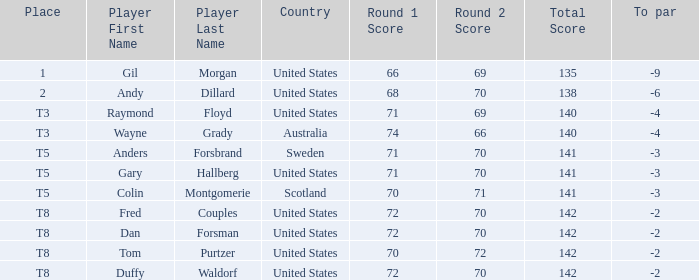Can you define the t8 place player? Fred Couples, Dan Forsman, Tom Purtzer, Duffy Waldorf. 